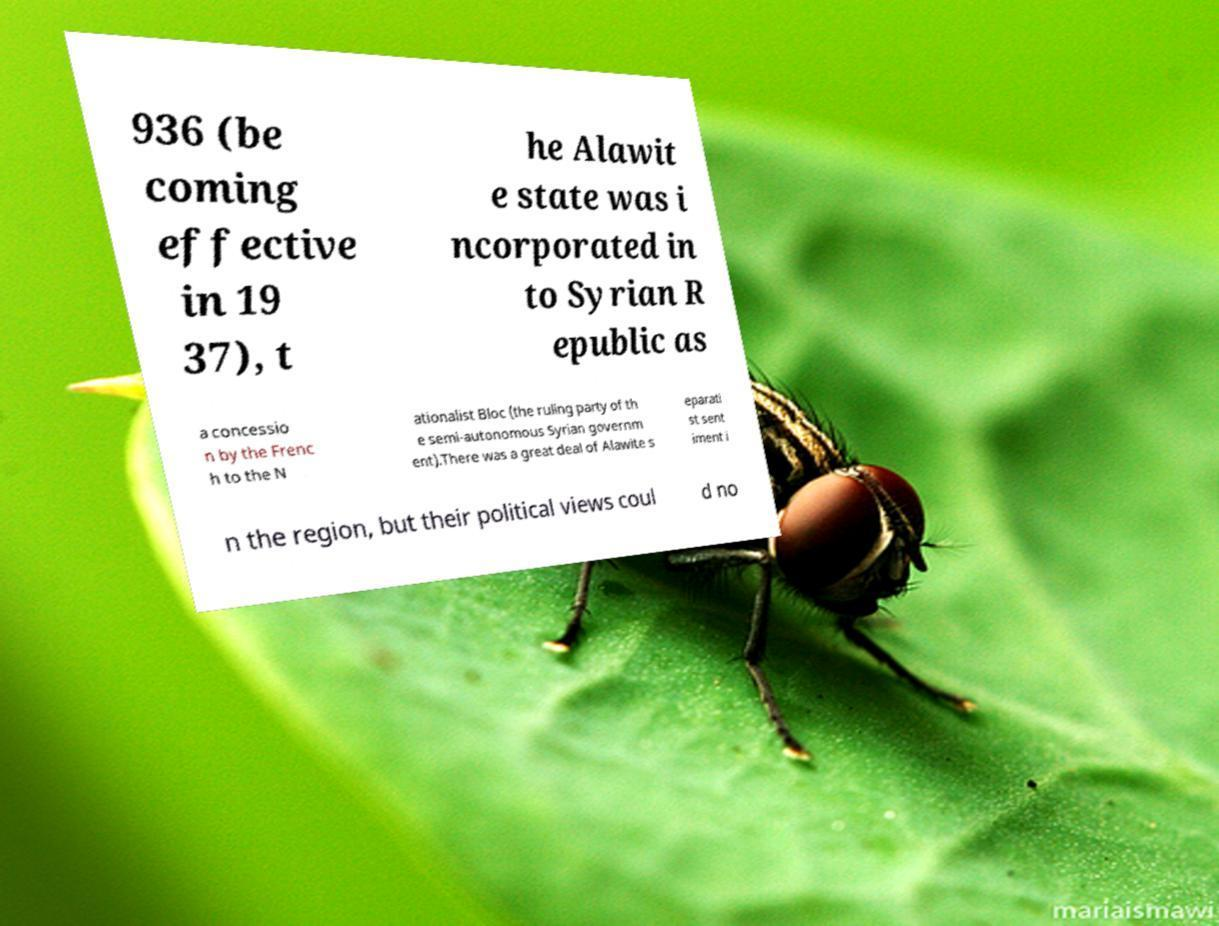Could you extract and type out the text from this image? 936 (be coming effective in 19 37), t he Alawit e state was i ncorporated in to Syrian R epublic as a concessio n by the Frenc h to the N ationalist Bloc (the ruling party of th e semi-autonomous Syrian governm ent).There was a great deal of Alawite s eparati st sent iment i n the region, but their political views coul d no 